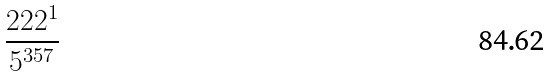<formula> <loc_0><loc_0><loc_500><loc_500>\frac { 2 2 2 ^ { 1 } } { 5 ^ { 3 5 7 } }</formula> 